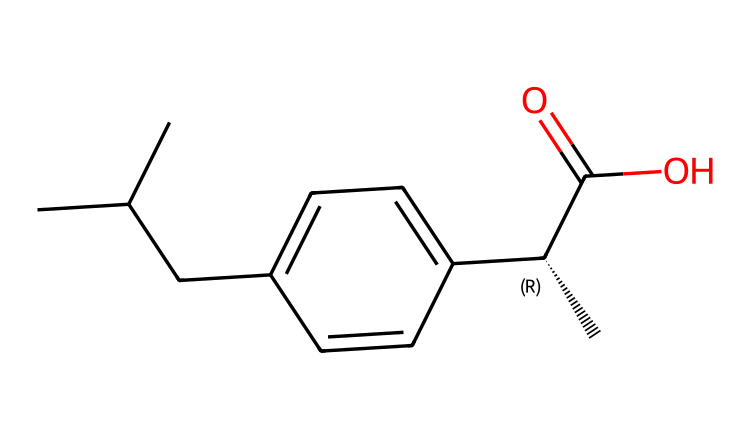What is the name of this chemical? The SMILES notation represents a specific molecular structure, which can be decoded to identify the chemical name. Analyzing the structure, it appears to represent ibuprofen, a common non-steroidal anti-inflammatory drug (NSAID).
Answer: ibuprofen How many carbon atoms are in this molecule? By analyzing the SMILES representation, we can count the carbon (C) atoms. The notation indicates there are 15 carbon atoms in total, including the ones in the cyclohexane ring and the side chains.
Answer: 15 What type of functional group is present in this chemical? The presence of the carboxylic acid moiety is evident from the "C(=O)O" part of the SMILES. This indicates that ibuprofen contains a carboxylic acid functional group, which is crucial for its anti-inflammatory activity.
Answer: carboxylic acid What is the role of the methylene bridge in this molecule? The methylene bridge (indicated by CC(C) and the C connecting the phenyl and carboxylic acid parts) helps to create a spatial arrangement that allows the molecule to effectively interact with the cyclooxygenase (COX) enzymes, which is essential for its anti-inflammatory effect.
Answer: carbons' connectivity How does ibuprofen inhibit inflammation? Ibuprofen inhibits inflammation primarily by blocking the action of the COX enzymes, which are involved in the synthesis of prostaglandins. The structure facilitates binding to these enzymes due to its configuration and functional groups, thus reducing pain and inflammation.
Answer: COX inhibition What is the molecular weight of ibuprofen? To calculate the molecular weight, we sum the atomic weights of all the atoms in the molecular structure represented by its SMILES. The total comes to approximately 206.29 grams per mole for ibuprofen.
Answer: 206.29 What is the significance of the stereocenter in this chemical? The "C@@H" notation in the SMILES indicates that there is a stereocenter in ibuprofen, affecting its bioactivity. Only one enantiomer is responsible for the therapeutic effect, while others may not be active or might cause side effects.
Answer: enantiomeric specificity 